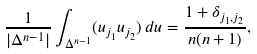<formula> <loc_0><loc_0><loc_500><loc_500>\frac { 1 } { | \Delta ^ { n - 1 } | } \int _ { \Delta ^ { n - 1 } } ( u _ { j _ { 1 } } u _ { j _ { 2 } } ) \, d u = \frac { 1 + \delta _ { j _ { 1 } , j _ { 2 } } } { n ( n + 1 ) } ,</formula> 